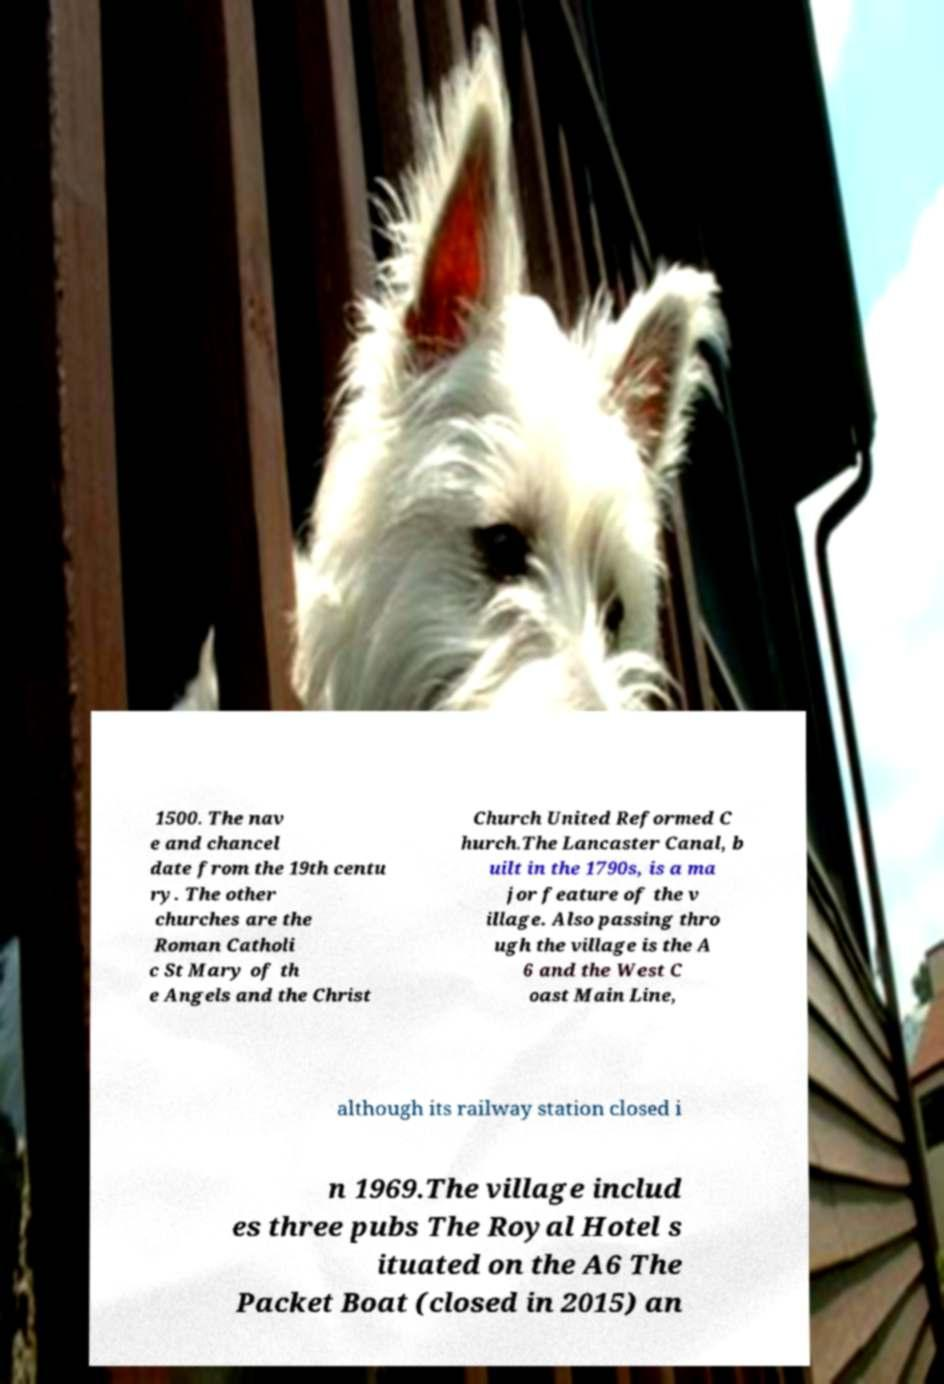For documentation purposes, I need the text within this image transcribed. Could you provide that? 1500. The nav e and chancel date from the 19th centu ry. The other churches are the Roman Catholi c St Mary of th e Angels and the Christ Church United Reformed C hurch.The Lancaster Canal, b uilt in the 1790s, is a ma jor feature of the v illage. Also passing thro ugh the village is the A 6 and the West C oast Main Line, although its railway station closed i n 1969.The village includ es three pubs The Royal Hotel s ituated on the A6 The Packet Boat (closed in 2015) an 